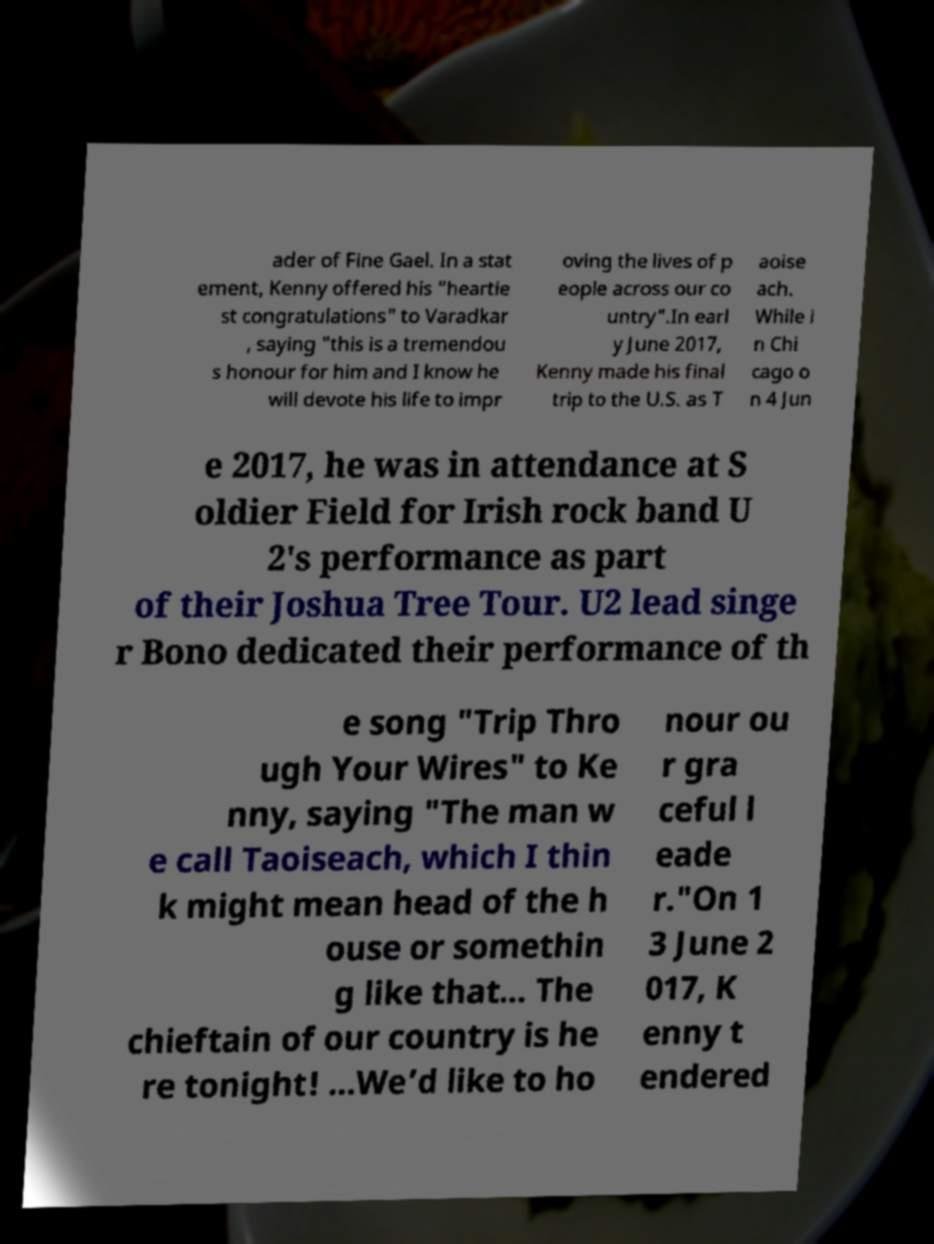Could you assist in decoding the text presented in this image and type it out clearly? ader of Fine Gael. In a stat ement, Kenny offered his "heartie st congratulations" to Varadkar , saying "this is a tremendou s honour for him and I know he will devote his life to impr oving the lives of p eople across our co untry".In earl y June 2017, Kenny made his final trip to the U.S. as T aoise ach. While i n Chi cago o n 4 Jun e 2017, he was in attendance at S oldier Field for Irish rock band U 2's performance as part of their Joshua Tree Tour. U2 lead singe r Bono dedicated their performance of th e song "Trip Thro ugh Your Wires" to Ke nny, saying "The man w e call Taoiseach, which I thin k might mean head of the h ouse or somethin g like that... The chieftain of our country is he re tonight! ...We’d like to ho nour ou r gra ceful l eade r."On 1 3 June 2 017, K enny t endered 